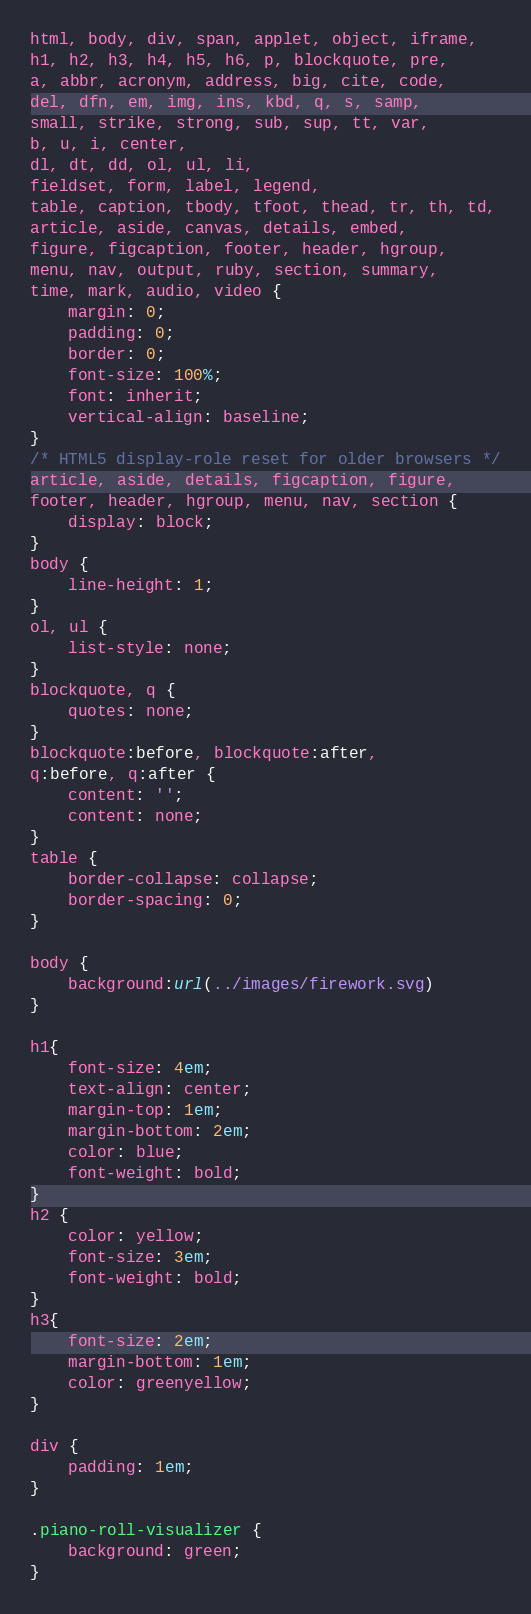<code> <loc_0><loc_0><loc_500><loc_500><_CSS_>html, body, div, span, applet, object, iframe,
h1, h2, h3, h4, h5, h6, p, blockquote, pre,
a, abbr, acronym, address, big, cite, code,
del, dfn, em, img, ins, kbd, q, s, samp,
small, strike, strong, sub, sup, tt, var,
b, u, i, center,
dl, dt, dd, ol, ul, li,
fieldset, form, label, legend,
table, caption, tbody, tfoot, thead, tr, th, td,
article, aside, canvas, details, embed, 
figure, figcaption, footer, header, hgroup, 
menu, nav, output, ruby, section, summary,
time, mark, audio, video {
	margin: 0;
	padding: 0;
	border: 0;
	font-size: 100%;
	font: inherit;
	vertical-align: baseline;
}
/* HTML5 display-role reset for older browsers */
article, aside, details, figcaption, figure, 
footer, header, hgroup, menu, nav, section {
	display: block;
}
body {
	line-height: 1;
}
ol, ul {
	list-style: none;
}
blockquote, q {
	quotes: none;
}
blockquote:before, blockquote:after,
q:before, q:after {
	content: '';
	content: none;
}
table {
	border-collapse: collapse;
	border-spacing: 0;
}

body {
    background:url(../images/firework.svg)
}

h1{
    font-size: 4em;
    text-align: center;
    margin-top: 1em;
    margin-bottom: 2em;
    color: blue;
    font-weight: bold;
}
h2 {
    color: yellow;
    font-size: 3em;
    font-weight: bold;
}
h3{
    font-size: 2em;
    margin-bottom: 1em;
    color: greenyellow;
}

div {
    padding: 1em;
}

.piano-roll-visualizer {
    background: green;
}</code> 